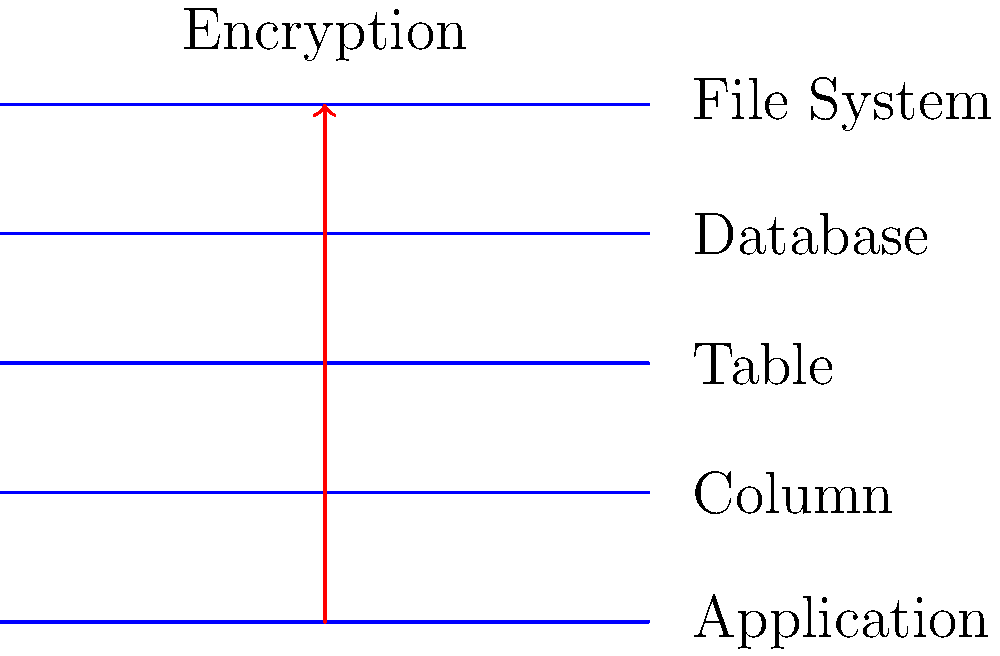In the diagram above, which layer of encryption would be most appropriate for protecting sensitive data in a specific column of a SQL database table, while allowing other columns to remain unencrypted? To determine the most appropriate layer of encryption for protecting sensitive data in a specific column of a SQL database table, let's analyze each layer from top to bottom:

1. Application Layer: This is too high-level and would typically encrypt data before it reaches the database, affecting all data.

2. Column Layer: This layer allows for encryption of specific columns within a table, which is ideal for protecting sensitive data while leaving other columns unencrypted.

3. Table Layer: Encrypting at this level would affect all columns in the table, which is more than required for the given scenario.

4. Database Layer: This would encrypt the entire database, which is excessive for protecting just one column.

5. File System Layer: This is the lowest level and would encrypt all data in the database files, which is not necessary for protecting a single column.

Given the requirement to protect sensitive data in a specific column while allowing other columns to remain unencrypted, the Column Layer (level 2 in the diagram) is the most appropriate choice. It provides granular control over which data is encrypted, allowing for selective protection of sensitive information.
Answer: Column Layer 